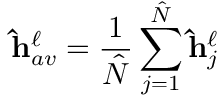Convert formula to latex. <formula><loc_0><loc_0><loc_500><loc_500>\hat { h } _ { a v } ^ { \ell } = \frac { 1 } { \hat { N } } \sum _ { j = 1 } ^ { \hat { N } } \hat { h } _ { j } ^ { \ell }</formula> 